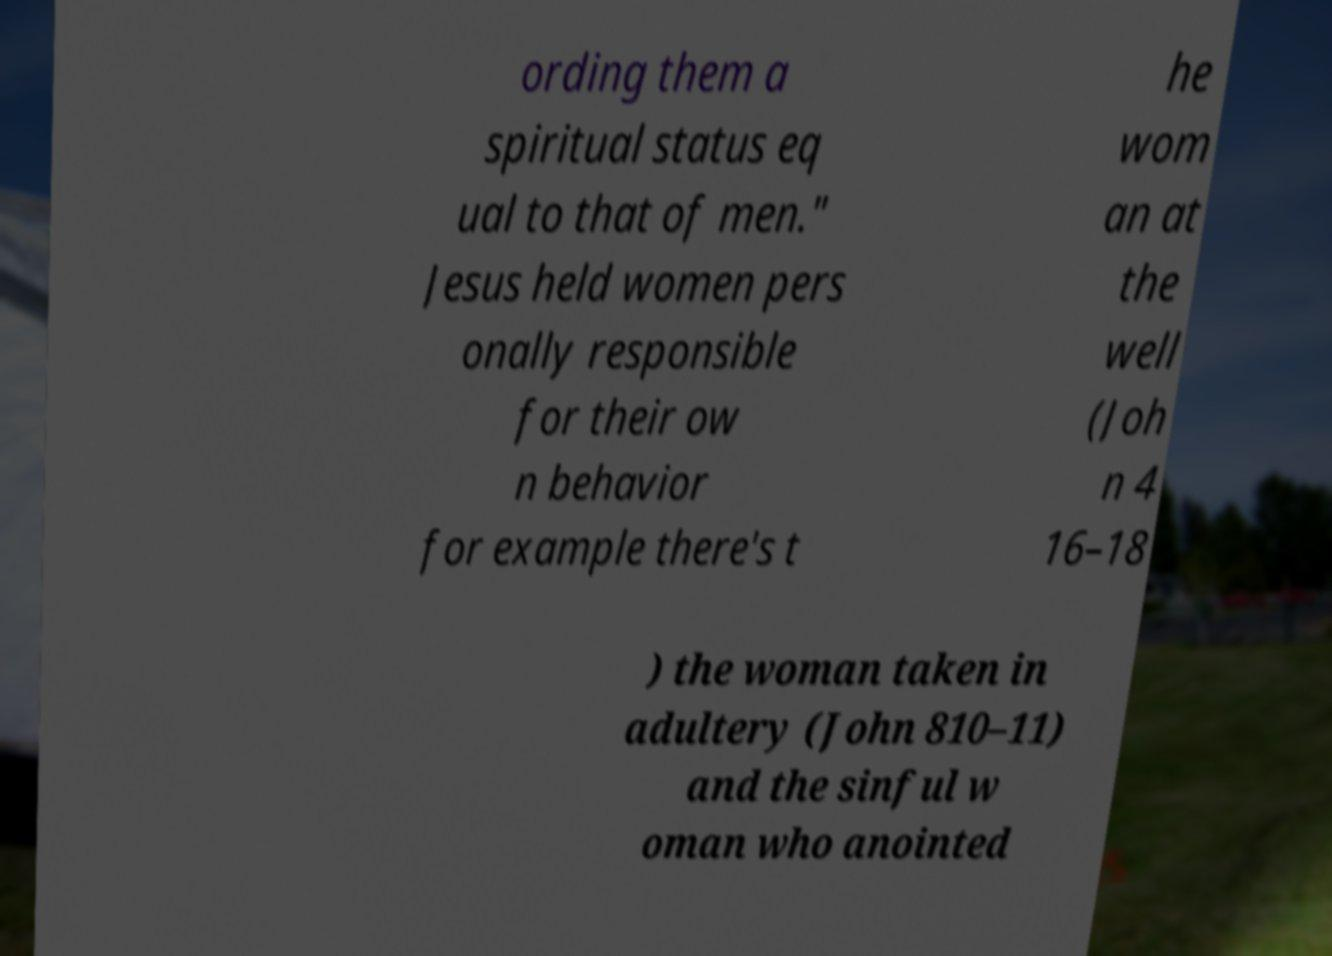For documentation purposes, I need the text within this image transcribed. Could you provide that? ording them a spiritual status eq ual to that of men." Jesus held women pers onally responsible for their ow n behavior for example there's t he wom an at the well (Joh n 4 16–18 ) the woman taken in adultery (John 810–11) and the sinful w oman who anointed 